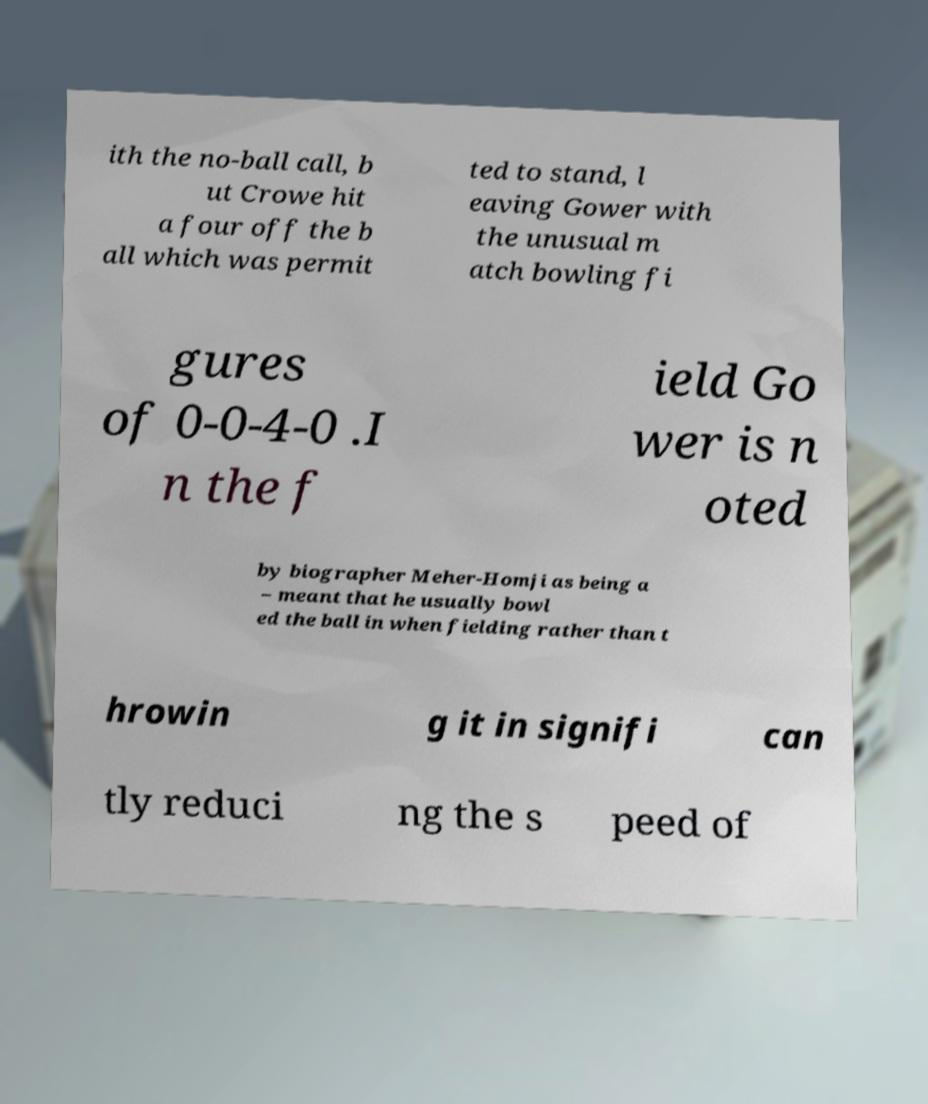Please identify and transcribe the text found in this image. ith the no-ball call, b ut Crowe hit a four off the b all which was permit ted to stand, l eaving Gower with the unusual m atch bowling fi gures of 0-0-4-0 .I n the f ield Go wer is n oted by biographer Meher-Homji as being a – meant that he usually bowl ed the ball in when fielding rather than t hrowin g it in signifi can tly reduci ng the s peed of 